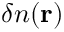<formula> <loc_0><loc_0><loc_500><loc_500>\delta n ( { \mathbf r } )</formula> 